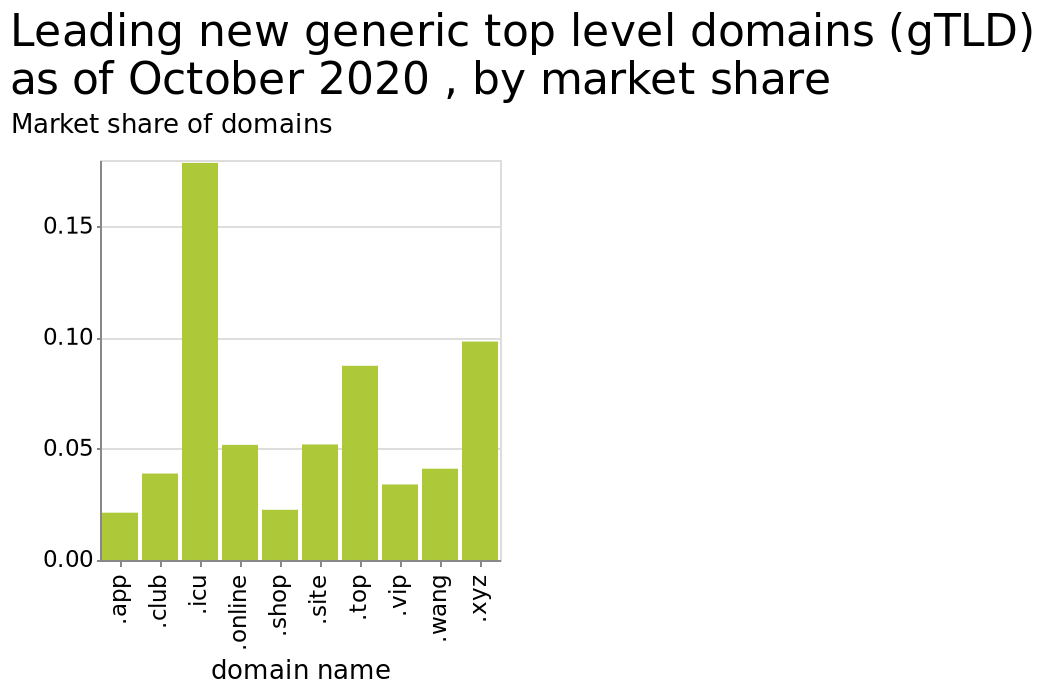<image>
Which domain is considered less important than others?  App is considered less important as it is the bottom level domain. What is the range of the y-axis on the bar graph?  The range of the y-axis on the bar graph is from 0.00 to 0.15. Offer a thorough analysis of the image. ICU is the new leading top level domain whilst app is the bottom. Is app considered more important as it is the top-level domain? No. App is considered less important as it is the bottom level domain. Is the range of the y-axis on the bar graph from 0.00 to 0.16? No. The range of the y-axis on the bar graph is from 0.00 to 0.15. 